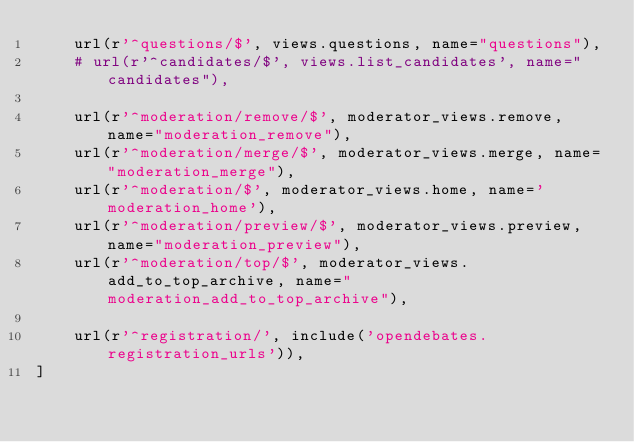<code> <loc_0><loc_0><loc_500><loc_500><_Python_>    url(r'^questions/$', views.questions, name="questions"),
    # url(r'^candidates/$', views.list_candidates', name="candidates"),

    url(r'^moderation/remove/$', moderator_views.remove, name="moderation_remove"),
    url(r'^moderation/merge/$', moderator_views.merge, name="moderation_merge"),
    url(r'^moderation/$', moderator_views.home, name='moderation_home'),
    url(r'^moderation/preview/$', moderator_views.preview, name="moderation_preview"),
    url(r'^moderation/top/$', moderator_views.add_to_top_archive, name="moderation_add_to_top_archive"),

    url(r'^registration/', include('opendebates.registration_urls')),
]
</code> 